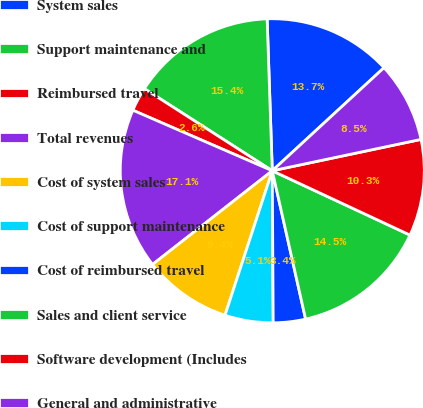Convert chart. <chart><loc_0><loc_0><loc_500><loc_500><pie_chart><fcel>System sales<fcel>Support maintenance and<fcel>Reimbursed travel<fcel>Total revenues<fcel>Cost of system sales<fcel>Cost of support maintenance<fcel>Cost of reimbursed travel<fcel>Sales and client service<fcel>Software development (Includes<fcel>General and administrative<nl><fcel>13.68%<fcel>15.38%<fcel>2.56%<fcel>17.09%<fcel>9.4%<fcel>5.13%<fcel>3.42%<fcel>14.53%<fcel>10.26%<fcel>8.55%<nl></chart> 